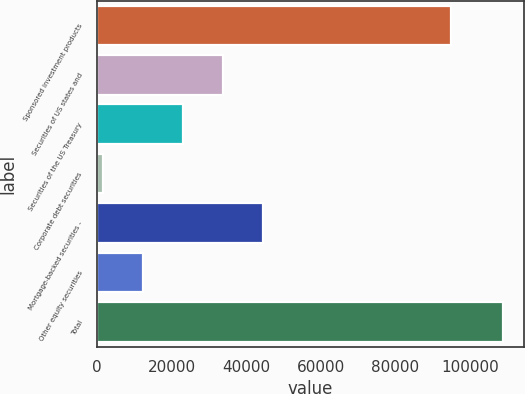Convert chart. <chart><loc_0><loc_0><loc_500><loc_500><bar_chart><fcel>Sponsored investment products<fcel>Securities of US states and<fcel>Securities of the US Treasury<fcel>Corporate debt securities<fcel>Mortgage-backed securities -<fcel>Other equity securities<fcel>Total<nl><fcel>94829<fcel>33741.8<fcel>22995.2<fcel>1502<fcel>44488.4<fcel>12248.6<fcel>108968<nl></chart> 